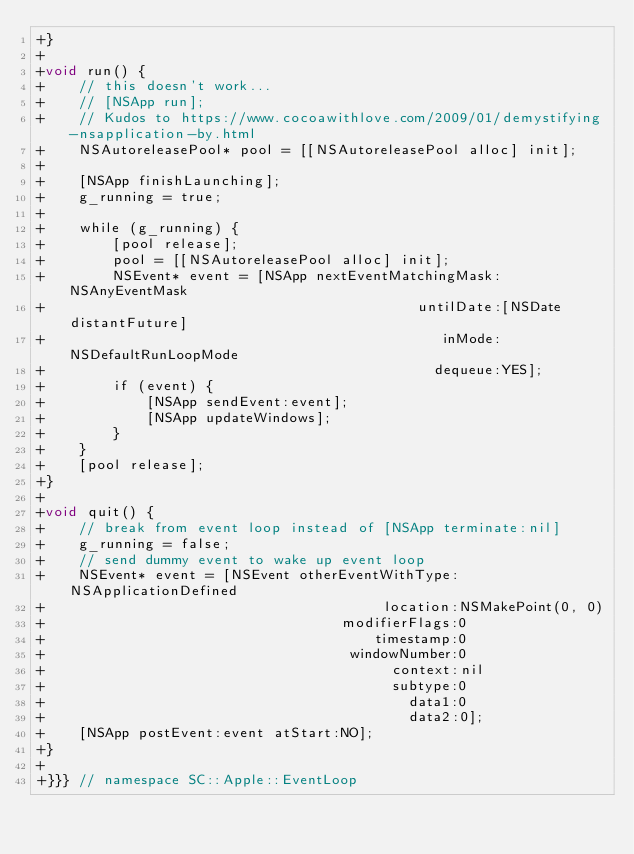<code> <loc_0><loc_0><loc_500><loc_500><_ObjectiveC_>+}
+
+void run() {
+    // this doesn't work...
+    // [NSApp run];
+    // Kudos to https://www.cocoawithlove.com/2009/01/demystifying-nsapplication-by.html
+    NSAutoreleasePool* pool = [[NSAutoreleasePool alloc] init];
+
+    [NSApp finishLaunching];
+    g_running = true;
+
+    while (g_running) {
+        [pool release];
+        pool = [[NSAutoreleasePool alloc] init];
+        NSEvent* event = [NSApp nextEventMatchingMask:NSAnyEventMask
+                                            untilDate:[NSDate distantFuture]
+                                               inMode:NSDefaultRunLoopMode
+                                              dequeue:YES];
+        if (event) {
+            [NSApp sendEvent:event];
+            [NSApp updateWindows];
+        }
+    }
+    [pool release];
+}
+
+void quit() {
+    // break from event loop instead of [NSApp terminate:nil]
+    g_running = false;
+    // send dummy event to wake up event loop
+    NSEvent* event = [NSEvent otherEventWithType:NSApplicationDefined
+                                        location:NSMakePoint(0, 0)
+                                   modifierFlags:0
+                                       timestamp:0
+                                    windowNumber:0
+                                         context:nil
+                                         subtype:0
+                                           data1:0
+                                           data2:0];
+    [NSApp postEvent:event atStart:NO];
+}
+
+}}} // namespace SC::Apple::EventLoop
</code> 